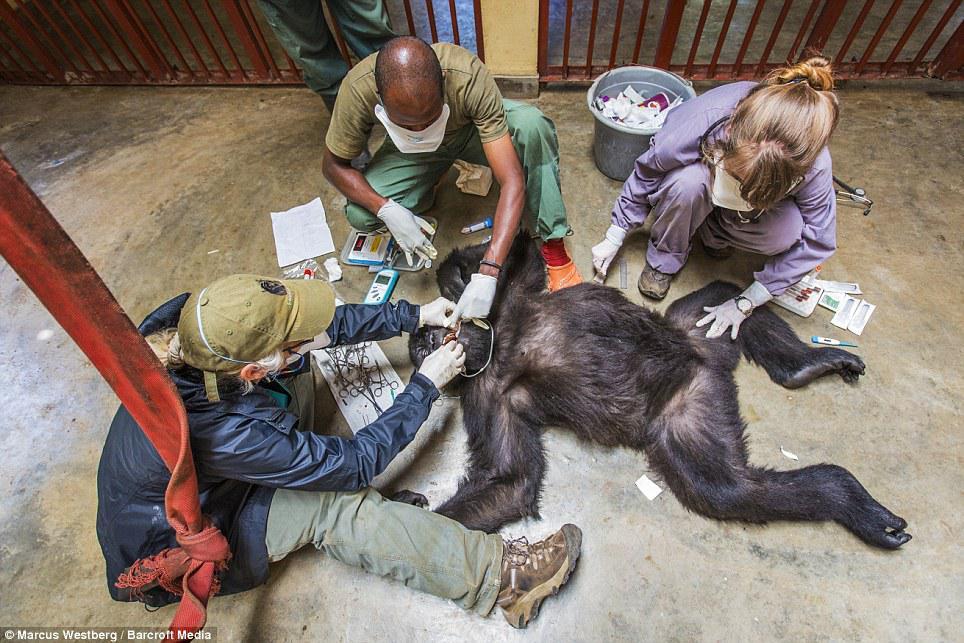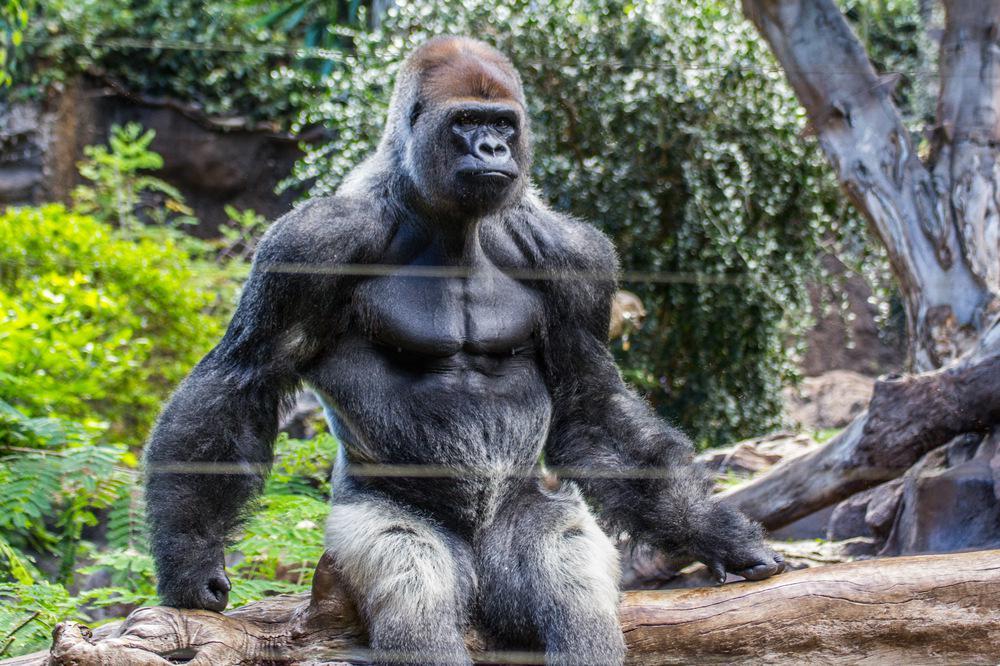The first image is the image on the left, the second image is the image on the right. Assess this claim about the two images: "One image shows multiple gorillas sitting on fallen logs in front of a massive tree trunk covered with twisted brown shapes.". Correct or not? Answer yes or no. No. The first image is the image on the left, the second image is the image on the right. For the images displayed, is the sentence "there are multiple gorillas sitting on logs in various sizes in front of a lasrge tree trunk" factually correct? Answer yes or no. No. 